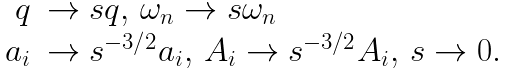Convert formula to latex. <formula><loc_0><loc_0><loc_500><loc_500>\begin{array} { r l } q & \rightarrow s q , \, \omega _ { n } \rightarrow s \omega _ { n } \\ a _ { i } & \rightarrow s ^ { - 3 / 2 } a _ { i } , \, A _ { i } \rightarrow s ^ { - 3 / 2 } A _ { i } , \, s \rightarrow 0 . \end{array}</formula> 